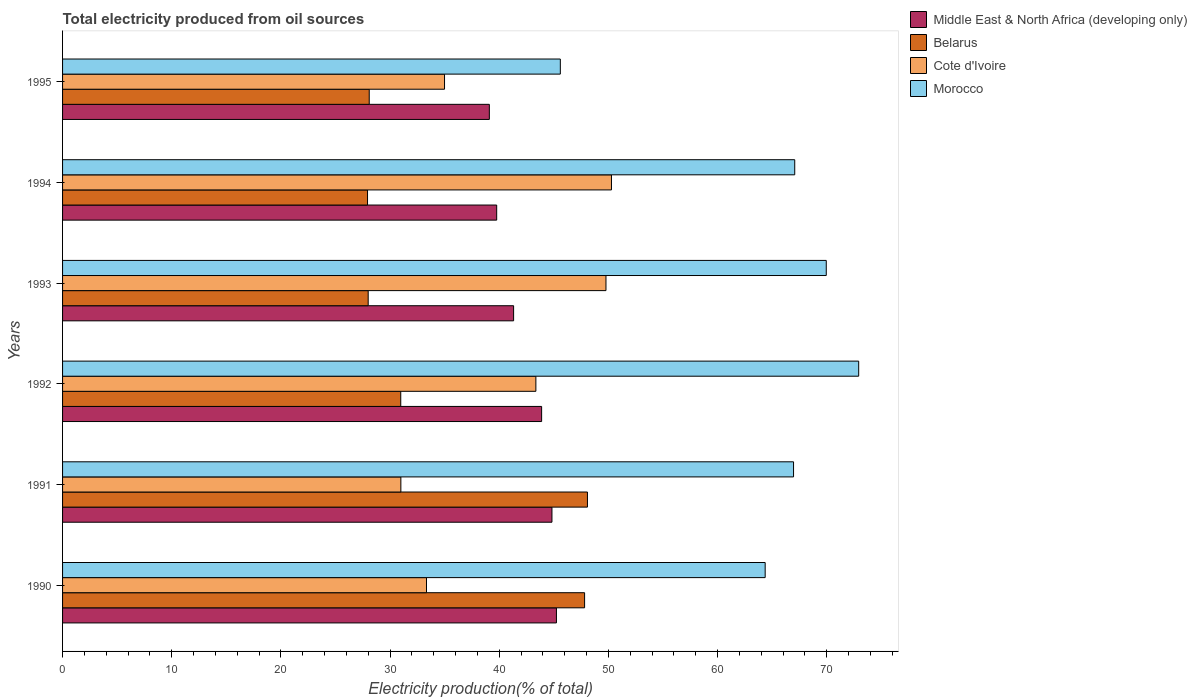How many different coloured bars are there?
Give a very brief answer. 4. How many groups of bars are there?
Provide a short and direct response. 6. Are the number of bars per tick equal to the number of legend labels?
Offer a very short reply. Yes. In how many cases, is the number of bars for a given year not equal to the number of legend labels?
Your response must be concise. 0. What is the total electricity produced in Middle East & North Africa (developing only) in 1995?
Your answer should be compact. 39.09. Across all years, what is the maximum total electricity produced in Morocco?
Offer a very short reply. 72.92. Across all years, what is the minimum total electricity produced in Cote d'Ivoire?
Provide a succinct answer. 30.99. What is the total total electricity produced in Middle East & North Africa (developing only) in the graph?
Provide a succinct answer. 254.1. What is the difference between the total electricity produced in Belarus in 1991 and that in 1993?
Your response must be concise. 20.08. What is the difference between the total electricity produced in Morocco in 1990 and the total electricity produced in Belarus in 1995?
Ensure brevity in your answer.  36.27. What is the average total electricity produced in Belarus per year?
Provide a short and direct response. 35.15. In the year 1991, what is the difference between the total electricity produced in Belarus and total electricity produced in Middle East & North Africa (developing only)?
Keep it short and to the point. 3.25. In how many years, is the total electricity produced in Middle East & North Africa (developing only) greater than 56 %?
Your answer should be compact. 0. What is the ratio of the total electricity produced in Morocco in 1994 to that in 1995?
Make the answer very short. 1.47. What is the difference between the highest and the second highest total electricity produced in Morocco?
Make the answer very short. 2.97. What is the difference between the highest and the lowest total electricity produced in Cote d'Ivoire?
Your response must be concise. 19.29. Is the sum of the total electricity produced in Middle East & North Africa (developing only) in 1991 and 1992 greater than the maximum total electricity produced in Belarus across all years?
Ensure brevity in your answer.  Yes. What does the 1st bar from the top in 1992 represents?
Make the answer very short. Morocco. What does the 3rd bar from the bottom in 1990 represents?
Make the answer very short. Cote d'Ivoire. Is it the case that in every year, the sum of the total electricity produced in Middle East & North Africa (developing only) and total electricity produced in Belarus is greater than the total electricity produced in Cote d'Ivoire?
Your answer should be very brief. Yes. Are all the bars in the graph horizontal?
Your answer should be compact. Yes. Are the values on the major ticks of X-axis written in scientific E-notation?
Provide a short and direct response. No. Does the graph contain any zero values?
Make the answer very short. No. Where does the legend appear in the graph?
Your response must be concise. Top right. How are the legend labels stacked?
Offer a terse response. Vertical. What is the title of the graph?
Ensure brevity in your answer.  Total electricity produced from oil sources. Does "Djibouti" appear as one of the legend labels in the graph?
Keep it short and to the point. No. What is the label or title of the X-axis?
Offer a very short reply. Electricity production(% of total). What is the Electricity production(% of total) in Middle East & North Africa (developing only) in 1990?
Offer a very short reply. 45.23. What is the Electricity production(% of total) of Belarus in 1990?
Ensure brevity in your answer.  47.81. What is the Electricity production(% of total) in Cote d'Ivoire in 1990?
Offer a terse response. 33.33. What is the Electricity production(% of total) in Morocco in 1990?
Your response must be concise. 64.35. What is the Electricity production(% of total) in Middle East & North Africa (developing only) in 1991?
Your answer should be very brief. 44.82. What is the Electricity production(% of total) in Belarus in 1991?
Ensure brevity in your answer.  48.08. What is the Electricity production(% of total) in Cote d'Ivoire in 1991?
Give a very brief answer. 30.99. What is the Electricity production(% of total) of Morocco in 1991?
Ensure brevity in your answer.  66.95. What is the Electricity production(% of total) of Middle East & North Africa (developing only) in 1992?
Provide a succinct answer. 43.88. What is the Electricity production(% of total) of Belarus in 1992?
Your response must be concise. 30.97. What is the Electricity production(% of total) of Cote d'Ivoire in 1992?
Provide a succinct answer. 43.35. What is the Electricity production(% of total) in Morocco in 1992?
Your answer should be compact. 72.92. What is the Electricity production(% of total) in Middle East & North Africa (developing only) in 1993?
Your response must be concise. 41.31. What is the Electricity production(% of total) of Belarus in 1993?
Keep it short and to the point. 27.99. What is the Electricity production(% of total) of Cote d'Ivoire in 1993?
Your answer should be compact. 49.77. What is the Electricity production(% of total) of Morocco in 1993?
Offer a very short reply. 69.95. What is the Electricity production(% of total) of Middle East & North Africa (developing only) in 1994?
Give a very brief answer. 39.76. What is the Electricity production(% of total) in Belarus in 1994?
Keep it short and to the point. 27.93. What is the Electricity production(% of total) of Cote d'Ivoire in 1994?
Provide a short and direct response. 50.28. What is the Electricity production(% of total) in Morocco in 1994?
Provide a succinct answer. 67.06. What is the Electricity production(% of total) of Middle East & North Africa (developing only) in 1995?
Make the answer very short. 39.09. What is the Electricity production(% of total) of Belarus in 1995?
Offer a very short reply. 28.09. What is the Electricity production(% of total) of Cote d'Ivoire in 1995?
Make the answer very short. 34.98. What is the Electricity production(% of total) of Morocco in 1995?
Your response must be concise. 45.59. Across all years, what is the maximum Electricity production(% of total) of Middle East & North Africa (developing only)?
Give a very brief answer. 45.23. Across all years, what is the maximum Electricity production(% of total) of Belarus?
Offer a very short reply. 48.08. Across all years, what is the maximum Electricity production(% of total) in Cote d'Ivoire?
Your answer should be very brief. 50.28. Across all years, what is the maximum Electricity production(% of total) of Morocco?
Offer a very short reply. 72.92. Across all years, what is the minimum Electricity production(% of total) in Middle East & North Africa (developing only)?
Your answer should be compact. 39.09. Across all years, what is the minimum Electricity production(% of total) of Belarus?
Offer a very short reply. 27.93. Across all years, what is the minimum Electricity production(% of total) of Cote d'Ivoire?
Your answer should be compact. 30.99. Across all years, what is the minimum Electricity production(% of total) in Morocco?
Your response must be concise. 45.59. What is the total Electricity production(% of total) of Middle East & North Africa (developing only) in the graph?
Provide a short and direct response. 254.1. What is the total Electricity production(% of total) in Belarus in the graph?
Your answer should be very brief. 210.88. What is the total Electricity production(% of total) of Cote d'Ivoire in the graph?
Give a very brief answer. 242.7. What is the total Electricity production(% of total) in Morocco in the graph?
Your answer should be very brief. 386.83. What is the difference between the Electricity production(% of total) of Middle East & North Africa (developing only) in 1990 and that in 1991?
Give a very brief answer. 0.41. What is the difference between the Electricity production(% of total) of Belarus in 1990 and that in 1991?
Provide a succinct answer. -0.26. What is the difference between the Electricity production(% of total) of Cote d'Ivoire in 1990 and that in 1991?
Give a very brief answer. 2.35. What is the difference between the Electricity production(% of total) of Morocco in 1990 and that in 1991?
Offer a terse response. -2.6. What is the difference between the Electricity production(% of total) of Middle East & North Africa (developing only) in 1990 and that in 1992?
Ensure brevity in your answer.  1.36. What is the difference between the Electricity production(% of total) in Belarus in 1990 and that in 1992?
Provide a short and direct response. 16.84. What is the difference between the Electricity production(% of total) in Cote d'Ivoire in 1990 and that in 1992?
Ensure brevity in your answer.  -10.02. What is the difference between the Electricity production(% of total) in Morocco in 1990 and that in 1992?
Offer a very short reply. -8.57. What is the difference between the Electricity production(% of total) of Middle East & North Africa (developing only) in 1990 and that in 1993?
Offer a terse response. 3.92. What is the difference between the Electricity production(% of total) in Belarus in 1990 and that in 1993?
Make the answer very short. 19.82. What is the difference between the Electricity production(% of total) in Cote d'Ivoire in 1990 and that in 1993?
Keep it short and to the point. -16.44. What is the difference between the Electricity production(% of total) in Morocco in 1990 and that in 1993?
Offer a terse response. -5.6. What is the difference between the Electricity production(% of total) in Middle East & North Africa (developing only) in 1990 and that in 1994?
Offer a terse response. 5.47. What is the difference between the Electricity production(% of total) of Belarus in 1990 and that in 1994?
Make the answer very short. 19.88. What is the difference between the Electricity production(% of total) of Cote d'Ivoire in 1990 and that in 1994?
Your answer should be compact. -16.94. What is the difference between the Electricity production(% of total) of Morocco in 1990 and that in 1994?
Your answer should be very brief. -2.71. What is the difference between the Electricity production(% of total) in Middle East & North Africa (developing only) in 1990 and that in 1995?
Ensure brevity in your answer.  6.14. What is the difference between the Electricity production(% of total) of Belarus in 1990 and that in 1995?
Offer a very short reply. 19.73. What is the difference between the Electricity production(% of total) of Cote d'Ivoire in 1990 and that in 1995?
Ensure brevity in your answer.  -1.65. What is the difference between the Electricity production(% of total) of Morocco in 1990 and that in 1995?
Ensure brevity in your answer.  18.76. What is the difference between the Electricity production(% of total) in Middle East & North Africa (developing only) in 1991 and that in 1992?
Offer a terse response. 0.95. What is the difference between the Electricity production(% of total) in Belarus in 1991 and that in 1992?
Your answer should be compact. 17.1. What is the difference between the Electricity production(% of total) of Cote d'Ivoire in 1991 and that in 1992?
Provide a short and direct response. -12.37. What is the difference between the Electricity production(% of total) in Morocco in 1991 and that in 1992?
Give a very brief answer. -5.97. What is the difference between the Electricity production(% of total) in Middle East & North Africa (developing only) in 1991 and that in 1993?
Give a very brief answer. 3.51. What is the difference between the Electricity production(% of total) of Belarus in 1991 and that in 1993?
Offer a very short reply. 20.08. What is the difference between the Electricity production(% of total) of Cote d'Ivoire in 1991 and that in 1993?
Ensure brevity in your answer.  -18.79. What is the difference between the Electricity production(% of total) of Morocco in 1991 and that in 1993?
Ensure brevity in your answer.  -3. What is the difference between the Electricity production(% of total) in Middle East & North Africa (developing only) in 1991 and that in 1994?
Make the answer very short. 5.06. What is the difference between the Electricity production(% of total) in Belarus in 1991 and that in 1994?
Ensure brevity in your answer.  20.14. What is the difference between the Electricity production(% of total) in Cote d'Ivoire in 1991 and that in 1994?
Offer a very short reply. -19.29. What is the difference between the Electricity production(% of total) in Morocco in 1991 and that in 1994?
Offer a very short reply. -0.11. What is the difference between the Electricity production(% of total) in Middle East & North Africa (developing only) in 1991 and that in 1995?
Your answer should be compact. 5.73. What is the difference between the Electricity production(% of total) of Belarus in 1991 and that in 1995?
Keep it short and to the point. 19.99. What is the difference between the Electricity production(% of total) in Cote d'Ivoire in 1991 and that in 1995?
Give a very brief answer. -4. What is the difference between the Electricity production(% of total) of Morocco in 1991 and that in 1995?
Offer a very short reply. 21.36. What is the difference between the Electricity production(% of total) of Middle East & North Africa (developing only) in 1992 and that in 1993?
Give a very brief answer. 2.57. What is the difference between the Electricity production(% of total) in Belarus in 1992 and that in 1993?
Keep it short and to the point. 2.98. What is the difference between the Electricity production(% of total) of Cote d'Ivoire in 1992 and that in 1993?
Provide a short and direct response. -6.42. What is the difference between the Electricity production(% of total) in Morocco in 1992 and that in 1993?
Make the answer very short. 2.97. What is the difference between the Electricity production(% of total) in Middle East & North Africa (developing only) in 1992 and that in 1994?
Your answer should be very brief. 4.12. What is the difference between the Electricity production(% of total) of Belarus in 1992 and that in 1994?
Your answer should be compact. 3.04. What is the difference between the Electricity production(% of total) in Cote d'Ivoire in 1992 and that in 1994?
Provide a succinct answer. -6.92. What is the difference between the Electricity production(% of total) of Morocco in 1992 and that in 1994?
Offer a terse response. 5.86. What is the difference between the Electricity production(% of total) in Middle East & North Africa (developing only) in 1992 and that in 1995?
Offer a terse response. 4.79. What is the difference between the Electricity production(% of total) of Belarus in 1992 and that in 1995?
Give a very brief answer. 2.89. What is the difference between the Electricity production(% of total) in Cote d'Ivoire in 1992 and that in 1995?
Keep it short and to the point. 8.37. What is the difference between the Electricity production(% of total) in Morocco in 1992 and that in 1995?
Offer a very short reply. 27.33. What is the difference between the Electricity production(% of total) in Middle East & North Africa (developing only) in 1993 and that in 1994?
Your response must be concise. 1.55. What is the difference between the Electricity production(% of total) in Belarus in 1993 and that in 1994?
Provide a short and direct response. 0.06. What is the difference between the Electricity production(% of total) in Cote d'Ivoire in 1993 and that in 1994?
Make the answer very short. -0.5. What is the difference between the Electricity production(% of total) in Morocco in 1993 and that in 1994?
Your answer should be very brief. 2.89. What is the difference between the Electricity production(% of total) of Middle East & North Africa (developing only) in 1993 and that in 1995?
Offer a very short reply. 2.22. What is the difference between the Electricity production(% of total) in Belarus in 1993 and that in 1995?
Your answer should be very brief. -0.1. What is the difference between the Electricity production(% of total) in Cote d'Ivoire in 1993 and that in 1995?
Offer a very short reply. 14.79. What is the difference between the Electricity production(% of total) in Morocco in 1993 and that in 1995?
Provide a short and direct response. 24.36. What is the difference between the Electricity production(% of total) of Middle East & North Africa (developing only) in 1994 and that in 1995?
Make the answer very short. 0.67. What is the difference between the Electricity production(% of total) of Belarus in 1994 and that in 1995?
Give a very brief answer. -0.16. What is the difference between the Electricity production(% of total) of Cote d'Ivoire in 1994 and that in 1995?
Provide a succinct answer. 15.29. What is the difference between the Electricity production(% of total) in Morocco in 1994 and that in 1995?
Your answer should be compact. 21.47. What is the difference between the Electricity production(% of total) in Middle East & North Africa (developing only) in 1990 and the Electricity production(% of total) in Belarus in 1991?
Keep it short and to the point. -2.84. What is the difference between the Electricity production(% of total) of Middle East & North Africa (developing only) in 1990 and the Electricity production(% of total) of Cote d'Ivoire in 1991?
Ensure brevity in your answer.  14.25. What is the difference between the Electricity production(% of total) in Middle East & North Africa (developing only) in 1990 and the Electricity production(% of total) in Morocco in 1991?
Offer a very short reply. -21.72. What is the difference between the Electricity production(% of total) of Belarus in 1990 and the Electricity production(% of total) of Cote d'Ivoire in 1991?
Give a very brief answer. 16.83. What is the difference between the Electricity production(% of total) in Belarus in 1990 and the Electricity production(% of total) in Morocco in 1991?
Ensure brevity in your answer.  -19.14. What is the difference between the Electricity production(% of total) of Cote d'Ivoire in 1990 and the Electricity production(% of total) of Morocco in 1991?
Your answer should be compact. -33.62. What is the difference between the Electricity production(% of total) in Middle East & North Africa (developing only) in 1990 and the Electricity production(% of total) in Belarus in 1992?
Ensure brevity in your answer.  14.26. What is the difference between the Electricity production(% of total) of Middle East & North Africa (developing only) in 1990 and the Electricity production(% of total) of Cote d'Ivoire in 1992?
Offer a terse response. 1.88. What is the difference between the Electricity production(% of total) in Middle East & North Africa (developing only) in 1990 and the Electricity production(% of total) in Morocco in 1992?
Your answer should be compact. -27.68. What is the difference between the Electricity production(% of total) of Belarus in 1990 and the Electricity production(% of total) of Cote d'Ivoire in 1992?
Keep it short and to the point. 4.46. What is the difference between the Electricity production(% of total) in Belarus in 1990 and the Electricity production(% of total) in Morocco in 1992?
Keep it short and to the point. -25.1. What is the difference between the Electricity production(% of total) in Cote d'Ivoire in 1990 and the Electricity production(% of total) in Morocco in 1992?
Your answer should be compact. -39.59. What is the difference between the Electricity production(% of total) of Middle East & North Africa (developing only) in 1990 and the Electricity production(% of total) of Belarus in 1993?
Your answer should be very brief. 17.24. What is the difference between the Electricity production(% of total) in Middle East & North Africa (developing only) in 1990 and the Electricity production(% of total) in Cote d'Ivoire in 1993?
Offer a terse response. -4.54. What is the difference between the Electricity production(% of total) of Middle East & North Africa (developing only) in 1990 and the Electricity production(% of total) of Morocco in 1993?
Provide a succinct answer. -24.72. What is the difference between the Electricity production(% of total) of Belarus in 1990 and the Electricity production(% of total) of Cote d'Ivoire in 1993?
Make the answer very short. -1.96. What is the difference between the Electricity production(% of total) in Belarus in 1990 and the Electricity production(% of total) in Morocco in 1993?
Your answer should be very brief. -22.14. What is the difference between the Electricity production(% of total) of Cote d'Ivoire in 1990 and the Electricity production(% of total) of Morocco in 1993?
Make the answer very short. -36.62. What is the difference between the Electricity production(% of total) of Middle East & North Africa (developing only) in 1990 and the Electricity production(% of total) of Belarus in 1994?
Offer a very short reply. 17.3. What is the difference between the Electricity production(% of total) of Middle East & North Africa (developing only) in 1990 and the Electricity production(% of total) of Cote d'Ivoire in 1994?
Offer a terse response. -5.04. What is the difference between the Electricity production(% of total) of Middle East & North Africa (developing only) in 1990 and the Electricity production(% of total) of Morocco in 1994?
Provide a succinct answer. -21.83. What is the difference between the Electricity production(% of total) of Belarus in 1990 and the Electricity production(% of total) of Cote d'Ivoire in 1994?
Keep it short and to the point. -2.46. What is the difference between the Electricity production(% of total) in Belarus in 1990 and the Electricity production(% of total) in Morocco in 1994?
Your answer should be compact. -19.25. What is the difference between the Electricity production(% of total) of Cote d'Ivoire in 1990 and the Electricity production(% of total) of Morocco in 1994?
Make the answer very short. -33.73. What is the difference between the Electricity production(% of total) of Middle East & North Africa (developing only) in 1990 and the Electricity production(% of total) of Belarus in 1995?
Provide a short and direct response. 17.15. What is the difference between the Electricity production(% of total) in Middle East & North Africa (developing only) in 1990 and the Electricity production(% of total) in Cote d'Ivoire in 1995?
Make the answer very short. 10.25. What is the difference between the Electricity production(% of total) in Middle East & North Africa (developing only) in 1990 and the Electricity production(% of total) in Morocco in 1995?
Ensure brevity in your answer.  -0.36. What is the difference between the Electricity production(% of total) in Belarus in 1990 and the Electricity production(% of total) in Cote d'Ivoire in 1995?
Provide a short and direct response. 12.83. What is the difference between the Electricity production(% of total) of Belarus in 1990 and the Electricity production(% of total) of Morocco in 1995?
Your answer should be compact. 2.22. What is the difference between the Electricity production(% of total) in Cote d'Ivoire in 1990 and the Electricity production(% of total) in Morocco in 1995?
Make the answer very short. -12.26. What is the difference between the Electricity production(% of total) in Middle East & North Africa (developing only) in 1991 and the Electricity production(% of total) in Belarus in 1992?
Offer a very short reply. 13.85. What is the difference between the Electricity production(% of total) in Middle East & North Africa (developing only) in 1991 and the Electricity production(% of total) in Cote d'Ivoire in 1992?
Provide a short and direct response. 1.47. What is the difference between the Electricity production(% of total) in Middle East & North Africa (developing only) in 1991 and the Electricity production(% of total) in Morocco in 1992?
Your response must be concise. -28.09. What is the difference between the Electricity production(% of total) in Belarus in 1991 and the Electricity production(% of total) in Cote d'Ivoire in 1992?
Provide a succinct answer. 4.72. What is the difference between the Electricity production(% of total) of Belarus in 1991 and the Electricity production(% of total) of Morocco in 1992?
Ensure brevity in your answer.  -24.84. What is the difference between the Electricity production(% of total) in Cote d'Ivoire in 1991 and the Electricity production(% of total) in Morocco in 1992?
Give a very brief answer. -41.93. What is the difference between the Electricity production(% of total) of Middle East & North Africa (developing only) in 1991 and the Electricity production(% of total) of Belarus in 1993?
Keep it short and to the point. 16.83. What is the difference between the Electricity production(% of total) in Middle East & North Africa (developing only) in 1991 and the Electricity production(% of total) in Cote d'Ivoire in 1993?
Give a very brief answer. -4.95. What is the difference between the Electricity production(% of total) of Middle East & North Africa (developing only) in 1991 and the Electricity production(% of total) of Morocco in 1993?
Your response must be concise. -25.13. What is the difference between the Electricity production(% of total) in Belarus in 1991 and the Electricity production(% of total) in Cote d'Ivoire in 1993?
Provide a succinct answer. -1.7. What is the difference between the Electricity production(% of total) of Belarus in 1991 and the Electricity production(% of total) of Morocco in 1993?
Your answer should be compact. -21.87. What is the difference between the Electricity production(% of total) of Cote d'Ivoire in 1991 and the Electricity production(% of total) of Morocco in 1993?
Offer a very short reply. -38.96. What is the difference between the Electricity production(% of total) in Middle East & North Africa (developing only) in 1991 and the Electricity production(% of total) in Belarus in 1994?
Your answer should be compact. 16.89. What is the difference between the Electricity production(% of total) of Middle East & North Africa (developing only) in 1991 and the Electricity production(% of total) of Cote d'Ivoire in 1994?
Offer a very short reply. -5.45. What is the difference between the Electricity production(% of total) of Middle East & North Africa (developing only) in 1991 and the Electricity production(% of total) of Morocco in 1994?
Provide a short and direct response. -22.24. What is the difference between the Electricity production(% of total) in Belarus in 1991 and the Electricity production(% of total) in Cote d'Ivoire in 1994?
Provide a succinct answer. -2.2. What is the difference between the Electricity production(% of total) in Belarus in 1991 and the Electricity production(% of total) in Morocco in 1994?
Your answer should be very brief. -18.99. What is the difference between the Electricity production(% of total) of Cote d'Ivoire in 1991 and the Electricity production(% of total) of Morocco in 1994?
Offer a very short reply. -36.08. What is the difference between the Electricity production(% of total) in Middle East & North Africa (developing only) in 1991 and the Electricity production(% of total) in Belarus in 1995?
Give a very brief answer. 16.74. What is the difference between the Electricity production(% of total) in Middle East & North Africa (developing only) in 1991 and the Electricity production(% of total) in Cote d'Ivoire in 1995?
Offer a very short reply. 9.84. What is the difference between the Electricity production(% of total) of Middle East & North Africa (developing only) in 1991 and the Electricity production(% of total) of Morocco in 1995?
Your answer should be compact. -0.77. What is the difference between the Electricity production(% of total) in Belarus in 1991 and the Electricity production(% of total) in Cote d'Ivoire in 1995?
Provide a succinct answer. 13.09. What is the difference between the Electricity production(% of total) of Belarus in 1991 and the Electricity production(% of total) of Morocco in 1995?
Your answer should be very brief. 2.48. What is the difference between the Electricity production(% of total) of Cote d'Ivoire in 1991 and the Electricity production(% of total) of Morocco in 1995?
Ensure brevity in your answer.  -14.61. What is the difference between the Electricity production(% of total) of Middle East & North Africa (developing only) in 1992 and the Electricity production(% of total) of Belarus in 1993?
Offer a terse response. 15.88. What is the difference between the Electricity production(% of total) of Middle East & North Africa (developing only) in 1992 and the Electricity production(% of total) of Cote d'Ivoire in 1993?
Your response must be concise. -5.89. What is the difference between the Electricity production(% of total) of Middle East & North Africa (developing only) in 1992 and the Electricity production(% of total) of Morocco in 1993?
Provide a succinct answer. -26.07. What is the difference between the Electricity production(% of total) of Belarus in 1992 and the Electricity production(% of total) of Cote d'Ivoire in 1993?
Give a very brief answer. -18.8. What is the difference between the Electricity production(% of total) of Belarus in 1992 and the Electricity production(% of total) of Morocco in 1993?
Your response must be concise. -38.97. What is the difference between the Electricity production(% of total) in Cote d'Ivoire in 1992 and the Electricity production(% of total) in Morocco in 1993?
Make the answer very short. -26.6. What is the difference between the Electricity production(% of total) of Middle East & North Africa (developing only) in 1992 and the Electricity production(% of total) of Belarus in 1994?
Offer a terse response. 15.95. What is the difference between the Electricity production(% of total) of Middle East & North Africa (developing only) in 1992 and the Electricity production(% of total) of Cote d'Ivoire in 1994?
Provide a succinct answer. -6.4. What is the difference between the Electricity production(% of total) of Middle East & North Africa (developing only) in 1992 and the Electricity production(% of total) of Morocco in 1994?
Provide a short and direct response. -23.18. What is the difference between the Electricity production(% of total) in Belarus in 1992 and the Electricity production(% of total) in Cote d'Ivoire in 1994?
Make the answer very short. -19.3. What is the difference between the Electricity production(% of total) of Belarus in 1992 and the Electricity production(% of total) of Morocco in 1994?
Provide a short and direct response. -36.09. What is the difference between the Electricity production(% of total) in Cote d'Ivoire in 1992 and the Electricity production(% of total) in Morocco in 1994?
Provide a short and direct response. -23.71. What is the difference between the Electricity production(% of total) of Middle East & North Africa (developing only) in 1992 and the Electricity production(% of total) of Belarus in 1995?
Your answer should be compact. 15.79. What is the difference between the Electricity production(% of total) in Middle East & North Africa (developing only) in 1992 and the Electricity production(% of total) in Cote d'Ivoire in 1995?
Provide a succinct answer. 8.89. What is the difference between the Electricity production(% of total) of Middle East & North Africa (developing only) in 1992 and the Electricity production(% of total) of Morocco in 1995?
Provide a succinct answer. -1.71. What is the difference between the Electricity production(% of total) of Belarus in 1992 and the Electricity production(% of total) of Cote d'Ivoire in 1995?
Offer a very short reply. -4.01. What is the difference between the Electricity production(% of total) in Belarus in 1992 and the Electricity production(% of total) in Morocco in 1995?
Offer a very short reply. -14.62. What is the difference between the Electricity production(% of total) of Cote d'Ivoire in 1992 and the Electricity production(% of total) of Morocco in 1995?
Make the answer very short. -2.24. What is the difference between the Electricity production(% of total) of Middle East & North Africa (developing only) in 1993 and the Electricity production(% of total) of Belarus in 1994?
Your response must be concise. 13.38. What is the difference between the Electricity production(% of total) of Middle East & North Africa (developing only) in 1993 and the Electricity production(% of total) of Cote d'Ivoire in 1994?
Make the answer very short. -8.96. What is the difference between the Electricity production(% of total) in Middle East & North Africa (developing only) in 1993 and the Electricity production(% of total) in Morocco in 1994?
Keep it short and to the point. -25.75. What is the difference between the Electricity production(% of total) of Belarus in 1993 and the Electricity production(% of total) of Cote d'Ivoire in 1994?
Keep it short and to the point. -22.28. What is the difference between the Electricity production(% of total) of Belarus in 1993 and the Electricity production(% of total) of Morocco in 1994?
Your answer should be very brief. -39.07. What is the difference between the Electricity production(% of total) of Cote d'Ivoire in 1993 and the Electricity production(% of total) of Morocco in 1994?
Offer a terse response. -17.29. What is the difference between the Electricity production(% of total) in Middle East & North Africa (developing only) in 1993 and the Electricity production(% of total) in Belarus in 1995?
Ensure brevity in your answer.  13.22. What is the difference between the Electricity production(% of total) in Middle East & North Africa (developing only) in 1993 and the Electricity production(% of total) in Cote d'Ivoire in 1995?
Make the answer very short. 6.33. What is the difference between the Electricity production(% of total) of Middle East & North Africa (developing only) in 1993 and the Electricity production(% of total) of Morocco in 1995?
Provide a short and direct response. -4.28. What is the difference between the Electricity production(% of total) in Belarus in 1993 and the Electricity production(% of total) in Cote d'Ivoire in 1995?
Give a very brief answer. -6.99. What is the difference between the Electricity production(% of total) in Belarus in 1993 and the Electricity production(% of total) in Morocco in 1995?
Provide a succinct answer. -17.6. What is the difference between the Electricity production(% of total) in Cote d'Ivoire in 1993 and the Electricity production(% of total) in Morocco in 1995?
Give a very brief answer. 4.18. What is the difference between the Electricity production(% of total) in Middle East & North Africa (developing only) in 1994 and the Electricity production(% of total) in Belarus in 1995?
Your response must be concise. 11.67. What is the difference between the Electricity production(% of total) in Middle East & North Africa (developing only) in 1994 and the Electricity production(% of total) in Cote d'Ivoire in 1995?
Make the answer very short. 4.78. What is the difference between the Electricity production(% of total) in Middle East & North Africa (developing only) in 1994 and the Electricity production(% of total) in Morocco in 1995?
Make the answer very short. -5.83. What is the difference between the Electricity production(% of total) in Belarus in 1994 and the Electricity production(% of total) in Cote d'Ivoire in 1995?
Your response must be concise. -7.05. What is the difference between the Electricity production(% of total) of Belarus in 1994 and the Electricity production(% of total) of Morocco in 1995?
Make the answer very short. -17.66. What is the difference between the Electricity production(% of total) of Cote d'Ivoire in 1994 and the Electricity production(% of total) of Morocco in 1995?
Offer a terse response. 4.68. What is the average Electricity production(% of total) in Middle East & North Africa (developing only) per year?
Keep it short and to the point. 42.35. What is the average Electricity production(% of total) of Belarus per year?
Your answer should be compact. 35.15. What is the average Electricity production(% of total) of Cote d'Ivoire per year?
Your answer should be very brief. 40.45. What is the average Electricity production(% of total) of Morocco per year?
Offer a terse response. 64.47. In the year 1990, what is the difference between the Electricity production(% of total) of Middle East & North Africa (developing only) and Electricity production(% of total) of Belarus?
Provide a short and direct response. -2.58. In the year 1990, what is the difference between the Electricity production(% of total) of Middle East & North Africa (developing only) and Electricity production(% of total) of Cote d'Ivoire?
Give a very brief answer. 11.9. In the year 1990, what is the difference between the Electricity production(% of total) in Middle East & North Africa (developing only) and Electricity production(% of total) in Morocco?
Your answer should be very brief. -19.12. In the year 1990, what is the difference between the Electricity production(% of total) of Belarus and Electricity production(% of total) of Cote d'Ivoire?
Your response must be concise. 14.48. In the year 1990, what is the difference between the Electricity production(% of total) of Belarus and Electricity production(% of total) of Morocco?
Your answer should be very brief. -16.54. In the year 1990, what is the difference between the Electricity production(% of total) in Cote d'Ivoire and Electricity production(% of total) in Morocco?
Offer a terse response. -31.02. In the year 1991, what is the difference between the Electricity production(% of total) of Middle East & North Africa (developing only) and Electricity production(% of total) of Belarus?
Ensure brevity in your answer.  -3.25. In the year 1991, what is the difference between the Electricity production(% of total) of Middle East & North Africa (developing only) and Electricity production(% of total) of Cote d'Ivoire?
Provide a succinct answer. 13.84. In the year 1991, what is the difference between the Electricity production(% of total) of Middle East & North Africa (developing only) and Electricity production(% of total) of Morocco?
Give a very brief answer. -22.13. In the year 1991, what is the difference between the Electricity production(% of total) in Belarus and Electricity production(% of total) in Cote d'Ivoire?
Offer a very short reply. 17.09. In the year 1991, what is the difference between the Electricity production(% of total) of Belarus and Electricity production(% of total) of Morocco?
Ensure brevity in your answer.  -18.88. In the year 1991, what is the difference between the Electricity production(% of total) in Cote d'Ivoire and Electricity production(% of total) in Morocco?
Provide a short and direct response. -35.97. In the year 1992, what is the difference between the Electricity production(% of total) of Middle East & North Africa (developing only) and Electricity production(% of total) of Belarus?
Your answer should be very brief. 12.9. In the year 1992, what is the difference between the Electricity production(% of total) of Middle East & North Africa (developing only) and Electricity production(% of total) of Cote d'Ivoire?
Make the answer very short. 0.53. In the year 1992, what is the difference between the Electricity production(% of total) in Middle East & North Africa (developing only) and Electricity production(% of total) in Morocco?
Offer a very short reply. -29.04. In the year 1992, what is the difference between the Electricity production(% of total) in Belarus and Electricity production(% of total) in Cote d'Ivoire?
Ensure brevity in your answer.  -12.38. In the year 1992, what is the difference between the Electricity production(% of total) in Belarus and Electricity production(% of total) in Morocco?
Give a very brief answer. -41.94. In the year 1992, what is the difference between the Electricity production(% of total) in Cote d'Ivoire and Electricity production(% of total) in Morocco?
Provide a succinct answer. -29.57. In the year 1993, what is the difference between the Electricity production(% of total) of Middle East & North Africa (developing only) and Electricity production(% of total) of Belarus?
Keep it short and to the point. 13.32. In the year 1993, what is the difference between the Electricity production(% of total) in Middle East & North Africa (developing only) and Electricity production(% of total) in Cote d'Ivoire?
Provide a succinct answer. -8.46. In the year 1993, what is the difference between the Electricity production(% of total) of Middle East & North Africa (developing only) and Electricity production(% of total) of Morocco?
Offer a terse response. -28.64. In the year 1993, what is the difference between the Electricity production(% of total) of Belarus and Electricity production(% of total) of Cote d'Ivoire?
Ensure brevity in your answer.  -21.78. In the year 1993, what is the difference between the Electricity production(% of total) in Belarus and Electricity production(% of total) in Morocco?
Your answer should be very brief. -41.96. In the year 1993, what is the difference between the Electricity production(% of total) in Cote d'Ivoire and Electricity production(% of total) in Morocco?
Provide a short and direct response. -20.18. In the year 1994, what is the difference between the Electricity production(% of total) of Middle East & North Africa (developing only) and Electricity production(% of total) of Belarus?
Make the answer very short. 11.83. In the year 1994, what is the difference between the Electricity production(% of total) of Middle East & North Africa (developing only) and Electricity production(% of total) of Cote d'Ivoire?
Ensure brevity in your answer.  -10.51. In the year 1994, what is the difference between the Electricity production(% of total) of Middle East & North Africa (developing only) and Electricity production(% of total) of Morocco?
Provide a succinct answer. -27.3. In the year 1994, what is the difference between the Electricity production(% of total) of Belarus and Electricity production(% of total) of Cote d'Ivoire?
Give a very brief answer. -22.34. In the year 1994, what is the difference between the Electricity production(% of total) of Belarus and Electricity production(% of total) of Morocco?
Give a very brief answer. -39.13. In the year 1994, what is the difference between the Electricity production(% of total) in Cote d'Ivoire and Electricity production(% of total) in Morocco?
Your answer should be very brief. -16.79. In the year 1995, what is the difference between the Electricity production(% of total) of Middle East & North Africa (developing only) and Electricity production(% of total) of Belarus?
Provide a succinct answer. 11. In the year 1995, what is the difference between the Electricity production(% of total) in Middle East & North Africa (developing only) and Electricity production(% of total) in Cote d'Ivoire?
Offer a very short reply. 4.1. In the year 1995, what is the difference between the Electricity production(% of total) in Middle East & North Africa (developing only) and Electricity production(% of total) in Morocco?
Offer a terse response. -6.5. In the year 1995, what is the difference between the Electricity production(% of total) in Belarus and Electricity production(% of total) in Cote d'Ivoire?
Your answer should be compact. -6.9. In the year 1995, what is the difference between the Electricity production(% of total) in Belarus and Electricity production(% of total) in Morocco?
Keep it short and to the point. -17.5. In the year 1995, what is the difference between the Electricity production(% of total) of Cote d'Ivoire and Electricity production(% of total) of Morocco?
Give a very brief answer. -10.61. What is the ratio of the Electricity production(% of total) in Middle East & North Africa (developing only) in 1990 to that in 1991?
Your answer should be compact. 1.01. What is the ratio of the Electricity production(% of total) of Belarus in 1990 to that in 1991?
Your answer should be very brief. 0.99. What is the ratio of the Electricity production(% of total) in Cote d'Ivoire in 1990 to that in 1991?
Offer a very short reply. 1.08. What is the ratio of the Electricity production(% of total) in Morocco in 1990 to that in 1991?
Your response must be concise. 0.96. What is the ratio of the Electricity production(% of total) of Middle East & North Africa (developing only) in 1990 to that in 1992?
Make the answer very short. 1.03. What is the ratio of the Electricity production(% of total) in Belarus in 1990 to that in 1992?
Provide a succinct answer. 1.54. What is the ratio of the Electricity production(% of total) of Cote d'Ivoire in 1990 to that in 1992?
Your response must be concise. 0.77. What is the ratio of the Electricity production(% of total) in Morocco in 1990 to that in 1992?
Your response must be concise. 0.88. What is the ratio of the Electricity production(% of total) in Middle East & North Africa (developing only) in 1990 to that in 1993?
Give a very brief answer. 1.09. What is the ratio of the Electricity production(% of total) in Belarus in 1990 to that in 1993?
Provide a succinct answer. 1.71. What is the ratio of the Electricity production(% of total) of Cote d'Ivoire in 1990 to that in 1993?
Offer a terse response. 0.67. What is the ratio of the Electricity production(% of total) in Middle East & North Africa (developing only) in 1990 to that in 1994?
Ensure brevity in your answer.  1.14. What is the ratio of the Electricity production(% of total) of Belarus in 1990 to that in 1994?
Offer a terse response. 1.71. What is the ratio of the Electricity production(% of total) of Cote d'Ivoire in 1990 to that in 1994?
Your response must be concise. 0.66. What is the ratio of the Electricity production(% of total) in Morocco in 1990 to that in 1994?
Keep it short and to the point. 0.96. What is the ratio of the Electricity production(% of total) of Middle East & North Africa (developing only) in 1990 to that in 1995?
Give a very brief answer. 1.16. What is the ratio of the Electricity production(% of total) of Belarus in 1990 to that in 1995?
Your answer should be compact. 1.7. What is the ratio of the Electricity production(% of total) in Cote d'Ivoire in 1990 to that in 1995?
Your answer should be very brief. 0.95. What is the ratio of the Electricity production(% of total) in Morocco in 1990 to that in 1995?
Ensure brevity in your answer.  1.41. What is the ratio of the Electricity production(% of total) in Middle East & North Africa (developing only) in 1991 to that in 1992?
Offer a very short reply. 1.02. What is the ratio of the Electricity production(% of total) in Belarus in 1991 to that in 1992?
Give a very brief answer. 1.55. What is the ratio of the Electricity production(% of total) of Cote d'Ivoire in 1991 to that in 1992?
Your answer should be very brief. 0.71. What is the ratio of the Electricity production(% of total) in Morocco in 1991 to that in 1992?
Offer a very short reply. 0.92. What is the ratio of the Electricity production(% of total) of Middle East & North Africa (developing only) in 1991 to that in 1993?
Give a very brief answer. 1.08. What is the ratio of the Electricity production(% of total) of Belarus in 1991 to that in 1993?
Make the answer very short. 1.72. What is the ratio of the Electricity production(% of total) of Cote d'Ivoire in 1991 to that in 1993?
Give a very brief answer. 0.62. What is the ratio of the Electricity production(% of total) of Morocco in 1991 to that in 1993?
Provide a short and direct response. 0.96. What is the ratio of the Electricity production(% of total) in Middle East & North Africa (developing only) in 1991 to that in 1994?
Provide a short and direct response. 1.13. What is the ratio of the Electricity production(% of total) of Belarus in 1991 to that in 1994?
Offer a very short reply. 1.72. What is the ratio of the Electricity production(% of total) of Cote d'Ivoire in 1991 to that in 1994?
Ensure brevity in your answer.  0.62. What is the ratio of the Electricity production(% of total) in Middle East & North Africa (developing only) in 1991 to that in 1995?
Provide a short and direct response. 1.15. What is the ratio of the Electricity production(% of total) in Belarus in 1991 to that in 1995?
Provide a succinct answer. 1.71. What is the ratio of the Electricity production(% of total) in Cote d'Ivoire in 1991 to that in 1995?
Ensure brevity in your answer.  0.89. What is the ratio of the Electricity production(% of total) of Morocco in 1991 to that in 1995?
Keep it short and to the point. 1.47. What is the ratio of the Electricity production(% of total) in Middle East & North Africa (developing only) in 1992 to that in 1993?
Your answer should be very brief. 1.06. What is the ratio of the Electricity production(% of total) in Belarus in 1992 to that in 1993?
Give a very brief answer. 1.11. What is the ratio of the Electricity production(% of total) of Cote d'Ivoire in 1992 to that in 1993?
Give a very brief answer. 0.87. What is the ratio of the Electricity production(% of total) in Morocco in 1992 to that in 1993?
Your answer should be very brief. 1.04. What is the ratio of the Electricity production(% of total) of Middle East & North Africa (developing only) in 1992 to that in 1994?
Provide a succinct answer. 1.1. What is the ratio of the Electricity production(% of total) of Belarus in 1992 to that in 1994?
Your answer should be very brief. 1.11. What is the ratio of the Electricity production(% of total) in Cote d'Ivoire in 1992 to that in 1994?
Your response must be concise. 0.86. What is the ratio of the Electricity production(% of total) of Morocco in 1992 to that in 1994?
Give a very brief answer. 1.09. What is the ratio of the Electricity production(% of total) of Middle East & North Africa (developing only) in 1992 to that in 1995?
Keep it short and to the point. 1.12. What is the ratio of the Electricity production(% of total) in Belarus in 1992 to that in 1995?
Make the answer very short. 1.1. What is the ratio of the Electricity production(% of total) in Cote d'Ivoire in 1992 to that in 1995?
Your answer should be compact. 1.24. What is the ratio of the Electricity production(% of total) of Morocco in 1992 to that in 1995?
Provide a short and direct response. 1.6. What is the ratio of the Electricity production(% of total) of Middle East & North Africa (developing only) in 1993 to that in 1994?
Offer a very short reply. 1.04. What is the ratio of the Electricity production(% of total) in Belarus in 1993 to that in 1994?
Your response must be concise. 1. What is the ratio of the Electricity production(% of total) of Cote d'Ivoire in 1993 to that in 1994?
Keep it short and to the point. 0.99. What is the ratio of the Electricity production(% of total) in Morocco in 1993 to that in 1994?
Your answer should be very brief. 1.04. What is the ratio of the Electricity production(% of total) in Middle East & North Africa (developing only) in 1993 to that in 1995?
Make the answer very short. 1.06. What is the ratio of the Electricity production(% of total) in Belarus in 1993 to that in 1995?
Your answer should be compact. 1. What is the ratio of the Electricity production(% of total) in Cote d'Ivoire in 1993 to that in 1995?
Your answer should be compact. 1.42. What is the ratio of the Electricity production(% of total) of Morocco in 1993 to that in 1995?
Your answer should be very brief. 1.53. What is the ratio of the Electricity production(% of total) of Middle East & North Africa (developing only) in 1994 to that in 1995?
Make the answer very short. 1.02. What is the ratio of the Electricity production(% of total) in Cote d'Ivoire in 1994 to that in 1995?
Give a very brief answer. 1.44. What is the ratio of the Electricity production(% of total) in Morocco in 1994 to that in 1995?
Your answer should be compact. 1.47. What is the difference between the highest and the second highest Electricity production(% of total) in Middle East & North Africa (developing only)?
Make the answer very short. 0.41. What is the difference between the highest and the second highest Electricity production(% of total) of Belarus?
Offer a terse response. 0.26. What is the difference between the highest and the second highest Electricity production(% of total) of Cote d'Ivoire?
Offer a terse response. 0.5. What is the difference between the highest and the second highest Electricity production(% of total) of Morocco?
Provide a short and direct response. 2.97. What is the difference between the highest and the lowest Electricity production(% of total) of Middle East & North Africa (developing only)?
Your answer should be compact. 6.14. What is the difference between the highest and the lowest Electricity production(% of total) in Belarus?
Provide a short and direct response. 20.14. What is the difference between the highest and the lowest Electricity production(% of total) of Cote d'Ivoire?
Your answer should be very brief. 19.29. What is the difference between the highest and the lowest Electricity production(% of total) in Morocco?
Give a very brief answer. 27.33. 